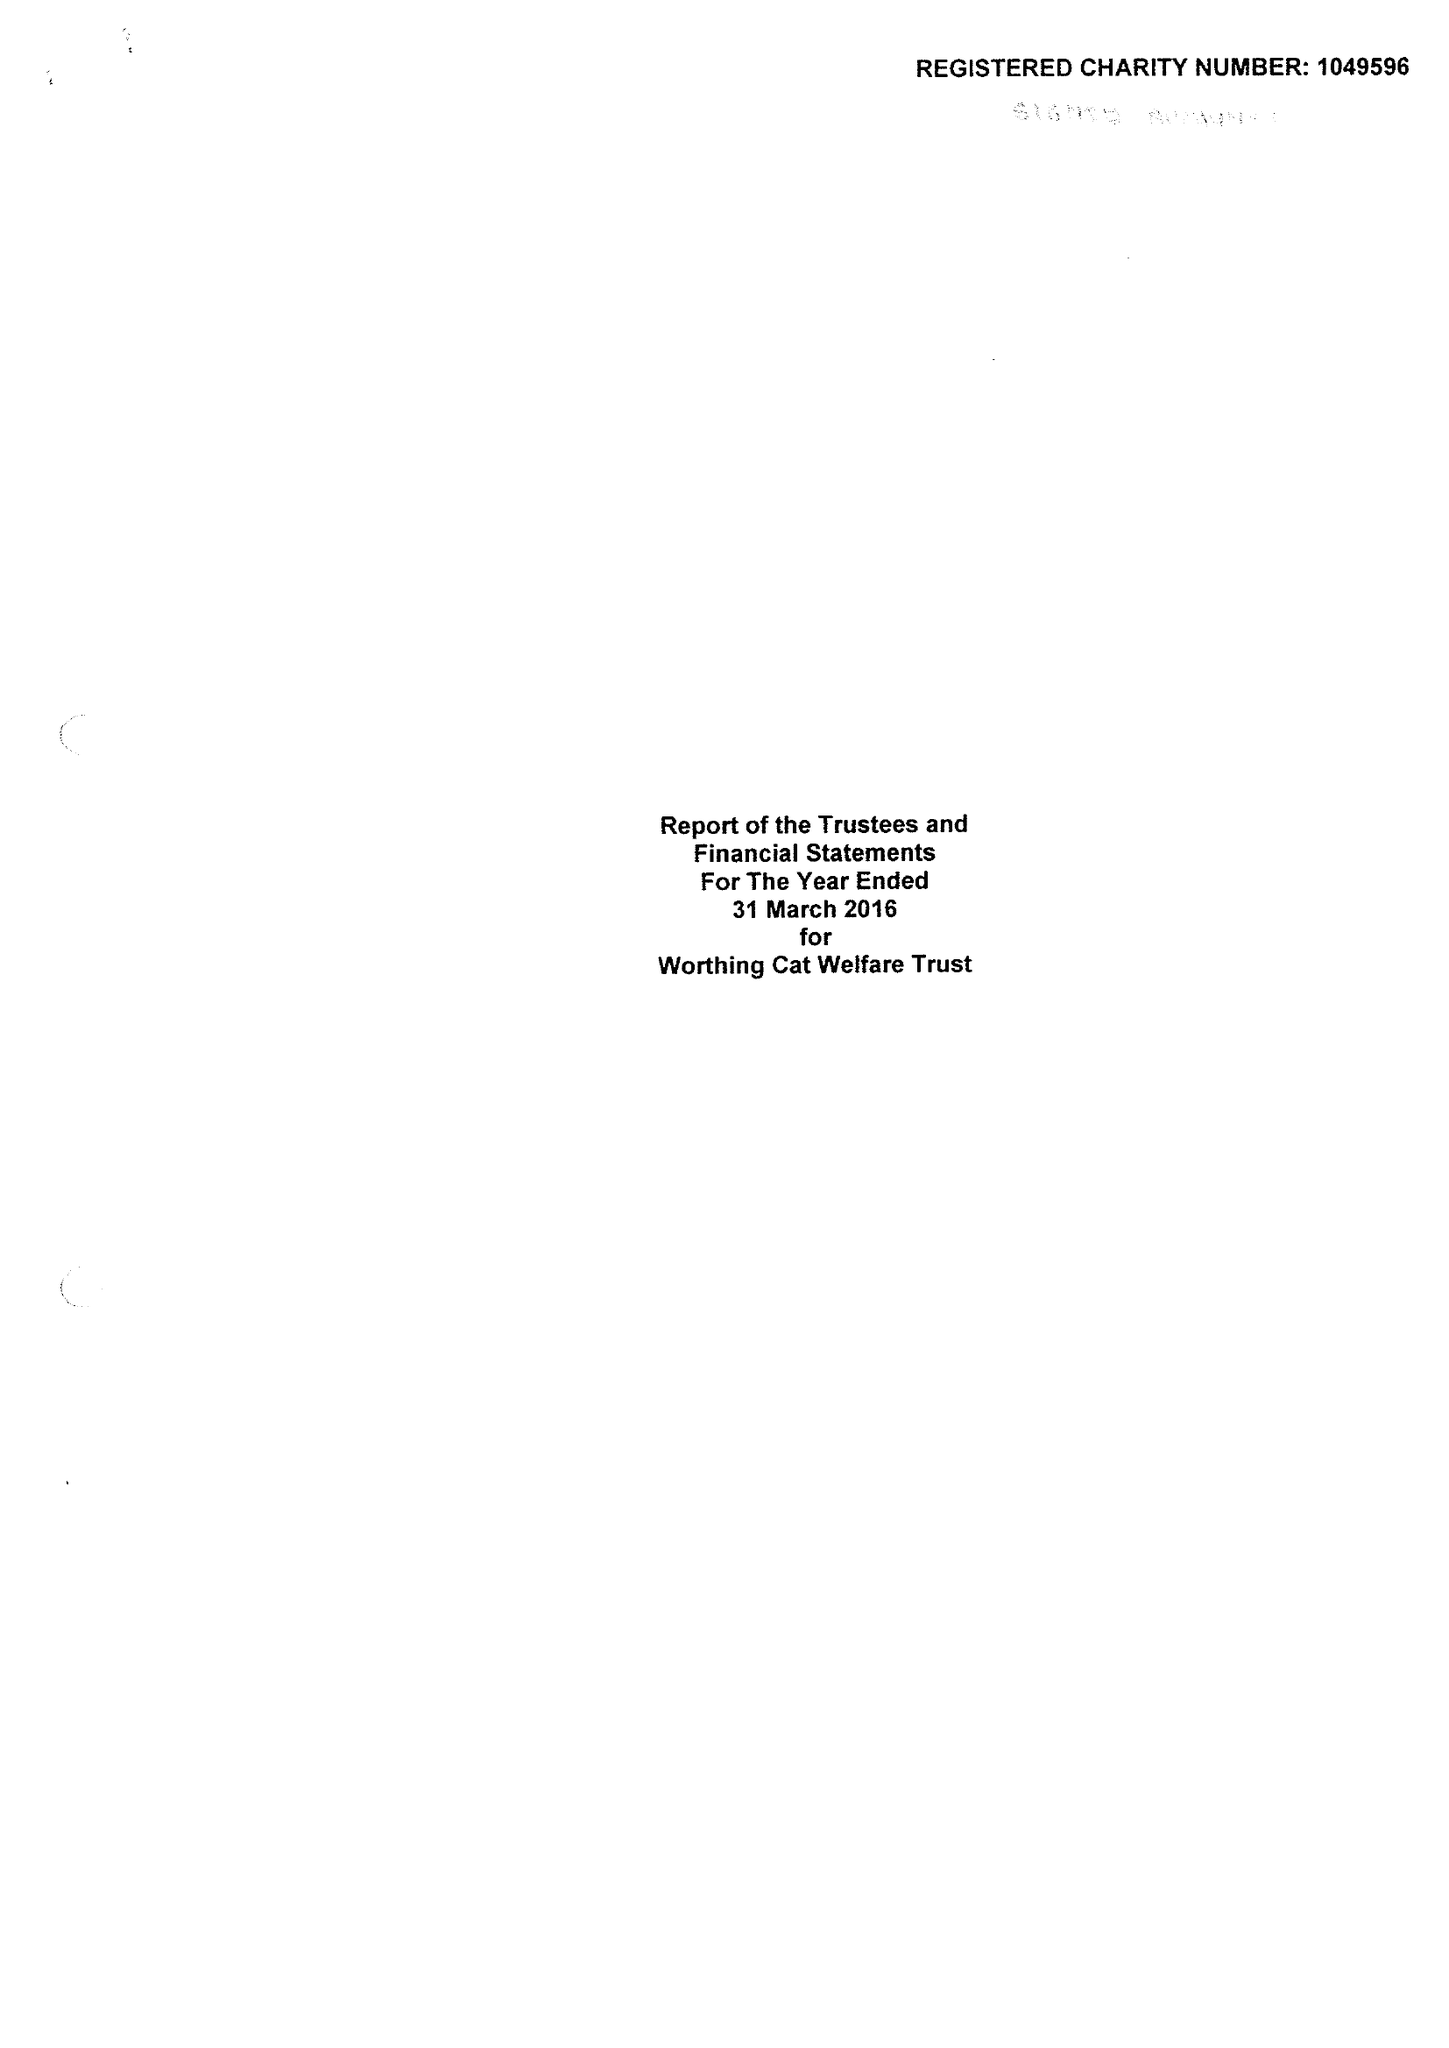What is the value for the charity_number?
Answer the question using a single word or phrase. 1049596 